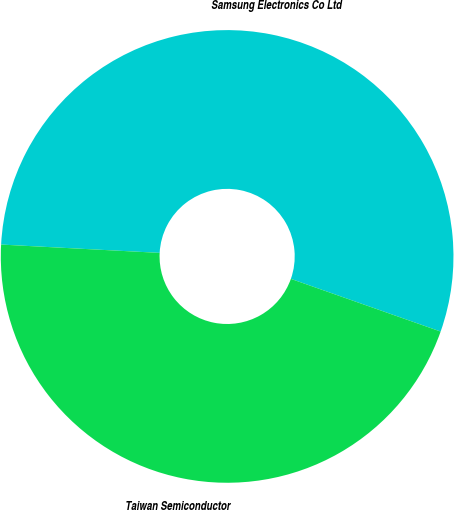<chart> <loc_0><loc_0><loc_500><loc_500><pie_chart><fcel>Samsung Electronics Co Ltd<fcel>Taiwan Semiconductor<nl><fcel>54.55%<fcel>45.45%<nl></chart> 